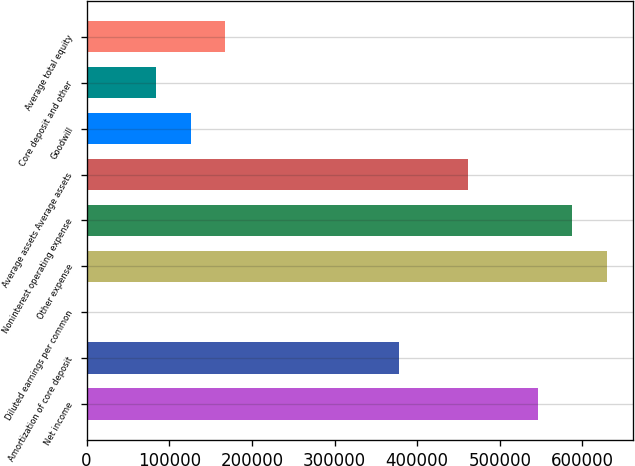<chart> <loc_0><loc_0><loc_500><loc_500><bar_chart><fcel>Net income<fcel>Amortization of core deposit<fcel>Diluted earnings per common<fcel>Other expense<fcel>Noninterest operating expense<fcel>Average assets Average assets<fcel>Goodwill<fcel>Core deposit and other<fcel>Average total equity<nl><fcel>545623<fcel>377739<fcel>1.44<fcel>629564<fcel>587593<fcel>461681<fcel>125914<fcel>83943.2<fcel>167885<nl></chart> 